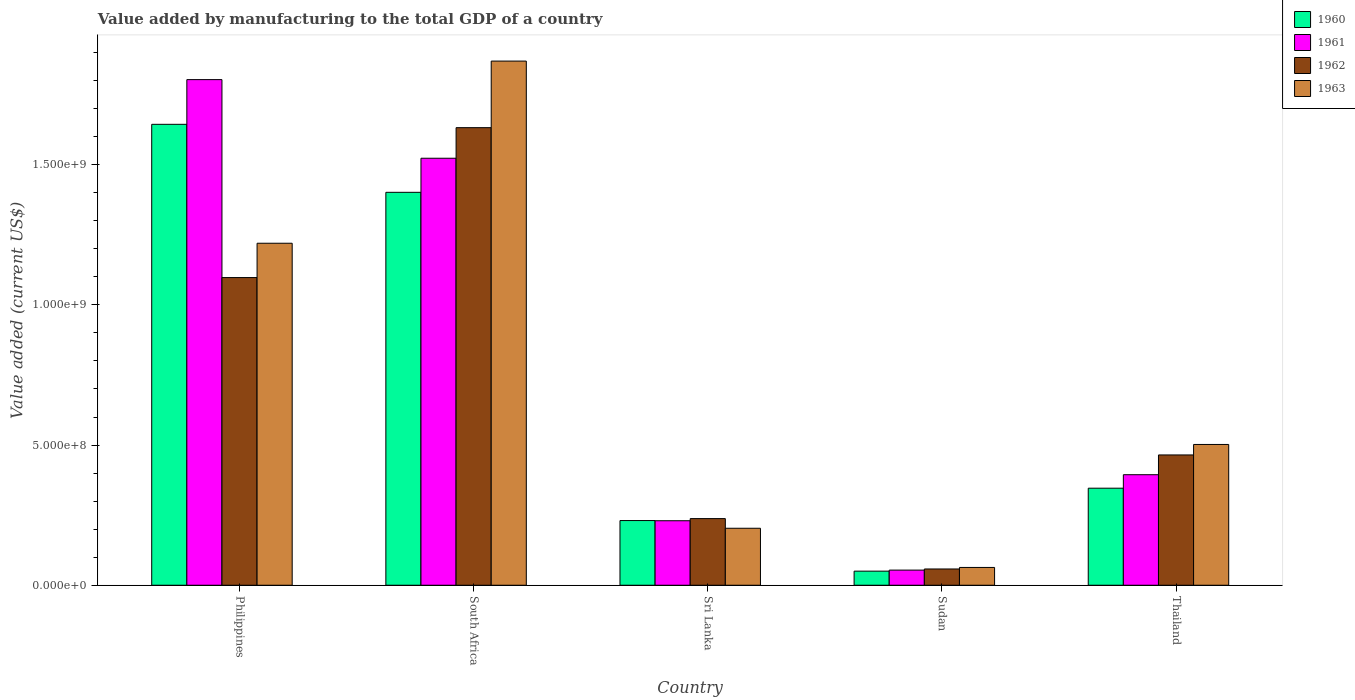How many different coloured bars are there?
Offer a terse response. 4. How many groups of bars are there?
Give a very brief answer. 5. Are the number of bars per tick equal to the number of legend labels?
Offer a terse response. Yes. Are the number of bars on each tick of the X-axis equal?
Keep it short and to the point. Yes. How many bars are there on the 2nd tick from the left?
Provide a succinct answer. 4. What is the label of the 5th group of bars from the left?
Give a very brief answer. Thailand. What is the value added by manufacturing to the total GDP in 1960 in South Africa?
Make the answer very short. 1.40e+09. Across all countries, what is the maximum value added by manufacturing to the total GDP in 1962?
Give a very brief answer. 1.63e+09. Across all countries, what is the minimum value added by manufacturing to the total GDP in 1961?
Provide a succinct answer. 5.40e+07. In which country was the value added by manufacturing to the total GDP in 1961 maximum?
Ensure brevity in your answer.  Philippines. In which country was the value added by manufacturing to the total GDP in 1961 minimum?
Make the answer very short. Sudan. What is the total value added by manufacturing to the total GDP in 1963 in the graph?
Your answer should be very brief. 3.86e+09. What is the difference between the value added by manufacturing to the total GDP in 1962 in South Africa and that in Thailand?
Your answer should be very brief. 1.17e+09. What is the difference between the value added by manufacturing to the total GDP in 1961 in Thailand and the value added by manufacturing to the total GDP in 1962 in Sudan?
Provide a short and direct response. 3.36e+08. What is the average value added by manufacturing to the total GDP in 1963 per country?
Keep it short and to the point. 7.72e+08. What is the difference between the value added by manufacturing to the total GDP of/in 1962 and value added by manufacturing to the total GDP of/in 1963 in Philippines?
Provide a succinct answer. -1.22e+08. In how many countries, is the value added by manufacturing to the total GDP in 1960 greater than 200000000 US$?
Offer a very short reply. 4. What is the ratio of the value added by manufacturing to the total GDP in 1963 in Sudan to that in Thailand?
Your answer should be compact. 0.13. Is the value added by manufacturing to the total GDP in 1963 in South Africa less than that in Sri Lanka?
Provide a short and direct response. No. Is the difference between the value added by manufacturing to the total GDP in 1962 in Philippines and Sudan greater than the difference between the value added by manufacturing to the total GDP in 1963 in Philippines and Sudan?
Ensure brevity in your answer.  No. What is the difference between the highest and the second highest value added by manufacturing to the total GDP in 1961?
Your answer should be compact. -1.13e+09. What is the difference between the highest and the lowest value added by manufacturing to the total GDP in 1963?
Your answer should be compact. 1.81e+09. In how many countries, is the value added by manufacturing to the total GDP in 1963 greater than the average value added by manufacturing to the total GDP in 1963 taken over all countries?
Provide a short and direct response. 2. Is the sum of the value added by manufacturing to the total GDP in 1962 in South Africa and Sri Lanka greater than the maximum value added by manufacturing to the total GDP in 1961 across all countries?
Provide a succinct answer. Yes. What does the 4th bar from the right in Sri Lanka represents?
Your response must be concise. 1960. How many bars are there?
Keep it short and to the point. 20. Are all the bars in the graph horizontal?
Your response must be concise. No. What is the difference between two consecutive major ticks on the Y-axis?
Your answer should be very brief. 5.00e+08. Are the values on the major ticks of Y-axis written in scientific E-notation?
Your answer should be very brief. Yes. Does the graph contain any zero values?
Provide a short and direct response. No. Does the graph contain grids?
Offer a very short reply. No. How many legend labels are there?
Your response must be concise. 4. How are the legend labels stacked?
Offer a terse response. Vertical. What is the title of the graph?
Your answer should be very brief. Value added by manufacturing to the total GDP of a country. Does "1960" appear as one of the legend labels in the graph?
Offer a very short reply. Yes. What is the label or title of the Y-axis?
Provide a short and direct response. Value added (current US$). What is the Value added (current US$) of 1960 in Philippines?
Your response must be concise. 1.64e+09. What is the Value added (current US$) of 1961 in Philippines?
Give a very brief answer. 1.80e+09. What is the Value added (current US$) in 1962 in Philippines?
Your answer should be very brief. 1.10e+09. What is the Value added (current US$) of 1963 in Philippines?
Your answer should be very brief. 1.22e+09. What is the Value added (current US$) in 1960 in South Africa?
Provide a succinct answer. 1.40e+09. What is the Value added (current US$) in 1961 in South Africa?
Give a very brief answer. 1.52e+09. What is the Value added (current US$) in 1962 in South Africa?
Make the answer very short. 1.63e+09. What is the Value added (current US$) in 1963 in South Africa?
Ensure brevity in your answer.  1.87e+09. What is the Value added (current US$) of 1960 in Sri Lanka?
Ensure brevity in your answer.  2.31e+08. What is the Value added (current US$) in 1961 in Sri Lanka?
Provide a short and direct response. 2.30e+08. What is the Value added (current US$) of 1962 in Sri Lanka?
Your response must be concise. 2.38e+08. What is the Value added (current US$) in 1963 in Sri Lanka?
Give a very brief answer. 2.03e+08. What is the Value added (current US$) of 1960 in Sudan?
Provide a short and direct response. 5.03e+07. What is the Value added (current US$) of 1961 in Sudan?
Provide a short and direct response. 5.40e+07. What is the Value added (current US$) of 1962 in Sudan?
Your answer should be very brief. 5.80e+07. What is the Value added (current US$) of 1963 in Sudan?
Provide a succinct answer. 6.35e+07. What is the Value added (current US$) in 1960 in Thailand?
Make the answer very short. 3.46e+08. What is the Value added (current US$) of 1961 in Thailand?
Your answer should be very brief. 3.94e+08. What is the Value added (current US$) of 1962 in Thailand?
Your answer should be very brief. 4.65e+08. What is the Value added (current US$) of 1963 in Thailand?
Give a very brief answer. 5.02e+08. Across all countries, what is the maximum Value added (current US$) of 1960?
Your response must be concise. 1.64e+09. Across all countries, what is the maximum Value added (current US$) in 1961?
Offer a very short reply. 1.80e+09. Across all countries, what is the maximum Value added (current US$) in 1962?
Keep it short and to the point. 1.63e+09. Across all countries, what is the maximum Value added (current US$) of 1963?
Ensure brevity in your answer.  1.87e+09. Across all countries, what is the minimum Value added (current US$) in 1960?
Give a very brief answer. 5.03e+07. Across all countries, what is the minimum Value added (current US$) of 1961?
Ensure brevity in your answer.  5.40e+07. Across all countries, what is the minimum Value added (current US$) of 1962?
Make the answer very short. 5.80e+07. Across all countries, what is the minimum Value added (current US$) in 1963?
Keep it short and to the point. 6.35e+07. What is the total Value added (current US$) in 1960 in the graph?
Keep it short and to the point. 3.67e+09. What is the total Value added (current US$) of 1961 in the graph?
Give a very brief answer. 4.00e+09. What is the total Value added (current US$) of 1962 in the graph?
Ensure brevity in your answer.  3.49e+09. What is the total Value added (current US$) of 1963 in the graph?
Provide a succinct answer. 3.86e+09. What is the difference between the Value added (current US$) in 1960 in Philippines and that in South Africa?
Give a very brief answer. 2.43e+08. What is the difference between the Value added (current US$) in 1961 in Philippines and that in South Africa?
Ensure brevity in your answer.  2.80e+08. What is the difference between the Value added (current US$) of 1962 in Philippines and that in South Africa?
Give a very brief answer. -5.35e+08. What is the difference between the Value added (current US$) in 1963 in Philippines and that in South Africa?
Your answer should be compact. -6.50e+08. What is the difference between the Value added (current US$) in 1960 in Philippines and that in Sri Lanka?
Your answer should be very brief. 1.41e+09. What is the difference between the Value added (current US$) of 1961 in Philippines and that in Sri Lanka?
Your answer should be compact. 1.57e+09. What is the difference between the Value added (current US$) of 1962 in Philippines and that in Sri Lanka?
Provide a short and direct response. 8.60e+08. What is the difference between the Value added (current US$) of 1963 in Philippines and that in Sri Lanka?
Offer a terse response. 1.02e+09. What is the difference between the Value added (current US$) of 1960 in Philippines and that in Sudan?
Your answer should be compact. 1.59e+09. What is the difference between the Value added (current US$) in 1961 in Philippines and that in Sudan?
Provide a short and direct response. 1.75e+09. What is the difference between the Value added (current US$) of 1962 in Philippines and that in Sudan?
Provide a short and direct response. 1.04e+09. What is the difference between the Value added (current US$) of 1963 in Philippines and that in Sudan?
Provide a short and direct response. 1.16e+09. What is the difference between the Value added (current US$) of 1960 in Philippines and that in Thailand?
Give a very brief answer. 1.30e+09. What is the difference between the Value added (current US$) in 1961 in Philippines and that in Thailand?
Ensure brevity in your answer.  1.41e+09. What is the difference between the Value added (current US$) of 1962 in Philippines and that in Thailand?
Offer a very short reply. 6.33e+08. What is the difference between the Value added (current US$) of 1963 in Philippines and that in Thailand?
Give a very brief answer. 7.18e+08. What is the difference between the Value added (current US$) of 1960 in South Africa and that in Sri Lanka?
Provide a short and direct response. 1.17e+09. What is the difference between the Value added (current US$) of 1961 in South Africa and that in Sri Lanka?
Give a very brief answer. 1.29e+09. What is the difference between the Value added (current US$) of 1962 in South Africa and that in Sri Lanka?
Keep it short and to the point. 1.39e+09. What is the difference between the Value added (current US$) in 1963 in South Africa and that in Sri Lanka?
Provide a short and direct response. 1.67e+09. What is the difference between the Value added (current US$) in 1960 in South Africa and that in Sudan?
Make the answer very short. 1.35e+09. What is the difference between the Value added (current US$) of 1961 in South Africa and that in Sudan?
Your answer should be compact. 1.47e+09. What is the difference between the Value added (current US$) of 1962 in South Africa and that in Sudan?
Your answer should be compact. 1.57e+09. What is the difference between the Value added (current US$) of 1963 in South Africa and that in Sudan?
Make the answer very short. 1.81e+09. What is the difference between the Value added (current US$) in 1960 in South Africa and that in Thailand?
Make the answer very short. 1.06e+09. What is the difference between the Value added (current US$) in 1961 in South Africa and that in Thailand?
Offer a very short reply. 1.13e+09. What is the difference between the Value added (current US$) in 1962 in South Africa and that in Thailand?
Your answer should be very brief. 1.17e+09. What is the difference between the Value added (current US$) of 1963 in South Africa and that in Thailand?
Ensure brevity in your answer.  1.37e+09. What is the difference between the Value added (current US$) in 1960 in Sri Lanka and that in Sudan?
Your response must be concise. 1.80e+08. What is the difference between the Value added (current US$) of 1961 in Sri Lanka and that in Sudan?
Your response must be concise. 1.76e+08. What is the difference between the Value added (current US$) of 1962 in Sri Lanka and that in Sudan?
Offer a terse response. 1.80e+08. What is the difference between the Value added (current US$) in 1963 in Sri Lanka and that in Sudan?
Offer a very short reply. 1.40e+08. What is the difference between the Value added (current US$) of 1960 in Sri Lanka and that in Thailand?
Your answer should be very brief. -1.15e+08. What is the difference between the Value added (current US$) of 1961 in Sri Lanka and that in Thailand?
Your answer should be compact. -1.64e+08. What is the difference between the Value added (current US$) of 1962 in Sri Lanka and that in Thailand?
Give a very brief answer. -2.27e+08. What is the difference between the Value added (current US$) of 1963 in Sri Lanka and that in Thailand?
Provide a short and direct response. -2.99e+08. What is the difference between the Value added (current US$) in 1960 in Sudan and that in Thailand?
Your answer should be compact. -2.96e+08. What is the difference between the Value added (current US$) in 1961 in Sudan and that in Thailand?
Provide a succinct answer. -3.40e+08. What is the difference between the Value added (current US$) of 1962 in Sudan and that in Thailand?
Your response must be concise. -4.07e+08. What is the difference between the Value added (current US$) in 1963 in Sudan and that in Thailand?
Ensure brevity in your answer.  -4.39e+08. What is the difference between the Value added (current US$) in 1960 in Philippines and the Value added (current US$) in 1961 in South Africa?
Ensure brevity in your answer.  1.21e+08. What is the difference between the Value added (current US$) of 1960 in Philippines and the Value added (current US$) of 1962 in South Africa?
Give a very brief answer. 1.19e+07. What is the difference between the Value added (current US$) of 1960 in Philippines and the Value added (current US$) of 1963 in South Africa?
Make the answer very short. -2.26e+08. What is the difference between the Value added (current US$) of 1961 in Philippines and the Value added (current US$) of 1962 in South Africa?
Provide a short and direct response. 1.71e+08. What is the difference between the Value added (current US$) of 1961 in Philippines and the Value added (current US$) of 1963 in South Africa?
Ensure brevity in your answer.  -6.61e+07. What is the difference between the Value added (current US$) of 1962 in Philippines and the Value added (current US$) of 1963 in South Africa?
Keep it short and to the point. -7.72e+08. What is the difference between the Value added (current US$) of 1960 in Philippines and the Value added (current US$) of 1961 in Sri Lanka?
Your answer should be compact. 1.41e+09. What is the difference between the Value added (current US$) of 1960 in Philippines and the Value added (current US$) of 1962 in Sri Lanka?
Ensure brevity in your answer.  1.41e+09. What is the difference between the Value added (current US$) of 1960 in Philippines and the Value added (current US$) of 1963 in Sri Lanka?
Your response must be concise. 1.44e+09. What is the difference between the Value added (current US$) of 1961 in Philippines and the Value added (current US$) of 1962 in Sri Lanka?
Your answer should be very brief. 1.57e+09. What is the difference between the Value added (current US$) in 1961 in Philippines and the Value added (current US$) in 1963 in Sri Lanka?
Provide a short and direct response. 1.60e+09. What is the difference between the Value added (current US$) of 1962 in Philippines and the Value added (current US$) of 1963 in Sri Lanka?
Ensure brevity in your answer.  8.94e+08. What is the difference between the Value added (current US$) in 1960 in Philippines and the Value added (current US$) in 1961 in Sudan?
Your answer should be compact. 1.59e+09. What is the difference between the Value added (current US$) of 1960 in Philippines and the Value added (current US$) of 1962 in Sudan?
Provide a succinct answer. 1.59e+09. What is the difference between the Value added (current US$) in 1960 in Philippines and the Value added (current US$) in 1963 in Sudan?
Give a very brief answer. 1.58e+09. What is the difference between the Value added (current US$) of 1961 in Philippines and the Value added (current US$) of 1962 in Sudan?
Provide a short and direct response. 1.75e+09. What is the difference between the Value added (current US$) of 1961 in Philippines and the Value added (current US$) of 1963 in Sudan?
Provide a succinct answer. 1.74e+09. What is the difference between the Value added (current US$) in 1962 in Philippines and the Value added (current US$) in 1963 in Sudan?
Provide a short and direct response. 1.03e+09. What is the difference between the Value added (current US$) of 1960 in Philippines and the Value added (current US$) of 1961 in Thailand?
Your response must be concise. 1.25e+09. What is the difference between the Value added (current US$) in 1960 in Philippines and the Value added (current US$) in 1962 in Thailand?
Provide a succinct answer. 1.18e+09. What is the difference between the Value added (current US$) in 1960 in Philippines and the Value added (current US$) in 1963 in Thailand?
Your answer should be very brief. 1.14e+09. What is the difference between the Value added (current US$) in 1961 in Philippines and the Value added (current US$) in 1962 in Thailand?
Make the answer very short. 1.34e+09. What is the difference between the Value added (current US$) of 1961 in Philippines and the Value added (current US$) of 1963 in Thailand?
Offer a terse response. 1.30e+09. What is the difference between the Value added (current US$) of 1962 in Philippines and the Value added (current US$) of 1963 in Thailand?
Keep it short and to the point. 5.95e+08. What is the difference between the Value added (current US$) of 1960 in South Africa and the Value added (current US$) of 1961 in Sri Lanka?
Offer a terse response. 1.17e+09. What is the difference between the Value added (current US$) of 1960 in South Africa and the Value added (current US$) of 1962 in Sri Lanka?
Your response must be concise. 1.16e+09. What is the difference between the Value added (current US$) in 1960 in South Africa and the Value added (current US$) in 1963 in Sri Lanka?
Your response must be concise. 1.20e+09. What is the difference between the Value added (current US$) of 1961 in South Africa and the Value added (current US$) of 1962 in Sri Lanka?
Give a very brief answer. 1.29e+09. What is the difference between the Value added (current US$) of 1961 in South Africa and the Value added (current US$) of 1963 in Sri Lanka?
Provide a succinct answer. 1.32e+09. What is the difference between the Value added (current US$) of 1962 in South Africa and the Value added (current US$) of 1963 in Sri Lanka?
Your response must be concise. 1.43e+09. What is the difference between the Value added (current US$) in 1960 in South Africa and the Value added (current US$) in 1961 in Sudan?
Your response must be concise. 1.35e+09. What is the difference between the Value added (current US$) in 1960 in South Africa and the Value added (current US$) in 1962 in Sudan?
Your answer should be very brief. 1.34e+09. What is the difference between the Value added (current US$) of 1960 in South Africa and the Value added (current US$) of 1963 in Sudan?
Your answer should be very brief. 1.34e+09. What is the difference between the Value added (current US$) of 1961 in South Africa and the Value added (current US$) of 1962 in Sudan?
Ensure brevity in your answer.  1.46e+09. What is the difference between the Value added (current US$) in 1961 in South Africa and the Value added (current US$) in 1963 in Sudan?
Your answer should be very brief. 1.46e+09. What is the difference between the Value added (current US$) of 1962 in South Africa and the Value added (current US$) of 1963 in Sudan?
Your answer should be very brief. 1.57e+09. What is the difference between the Value added (current US$) in 1960 in South Africa and the Value added (current US$) in 1961 in Thailand?
Offer a very short reply. 1.01e+09. What is the difference between the Value added (current US$) in 1960 in South Africa and the Value added (current US$) in 1962 in Thailand?
Keep it short and to the point. 9.37e+08. What is the difference between the Value added (current US$) in 1960 in South Africa and the Value added (current US$) in 1963 in Thailand?
Offer a terse response. 8.99e+08. What is the difference between the Value added (current US$) in 1961 in South Africa and the Value added (current US$) in 1962 in Thailand?
Your response must be concise. 1.06e+09. What is the difference between the Value added (current US$) of 1961 in South Africa and the Value added (current US$) of 1963 in Thailand?
Give a very brief answer. 1.02e+09. What is the difference between the Value added (current US$) in 1962 in South Africa and the Value added (current US$) in 1963 in Thailand?
Make the answer very short. 1.13e+09. What is the difference between the Value added (current US$) in 1960 in Sri Lanka and the Value added (current US$) in 1961 in Sudan?
Your answer should be compact. 1.77e+08. What is the difference between the Value added (current US$) of 1960 in Sri Lanka and the Value added (current US$) of 1962 in Sudan?
Make the answer very short. 1.73e+08. What is the difference between the Value added (current US$) in 1960 in Sri Lanka and the Value added (current US$) in 1963 in Sudan?
Provide a succinct answer. 1.67e+08. What is the difference between the Value added (current US$) in 1961 in Sri Lanka and the Value added (current US$) in 1962 in Sudan?
Keep it short and to the point. 1.72e+08. What is the difference between the Value added (current US$) of 1961 in Sri Lanka and the Value added (current US$) of 1963 in Sudan?
Provide a succinct answer. 1.67e+08. What is the difference between the Value added (current US$) in 1962 in Sri Lanka and the Value added (current US$) in 1963 in Sudan?
Your response must be concise. 1.74e+08. What is the difference between the Value added (current US$) of 1960 in Sri Lanka and the Value added (current US$) of 1961 in Thailand?
Ensure brevity in your answer.  -1.64e+08. What is the difference between the Value added (current US$) of 1960 in Sri Lanka and the Value added (current US$) of 1962 in Thailand?
Your answer should be very brief. -2.34e+08. What is the difference between the Value added (current US$) of 1960 in Sri Lanka and the Value added (current US$) of 1963 in Thailand?
Ensure brevity in your answer.  -2.71e+08. What is the difference between the Value added (current US$) of 1961 in Sri Lanka and the Value added (current US$) of 1962 in Thailand?
Provide a short and direct response. -2.35e+08. What is the difference between the Value added (current US$) in 1961 in Sri Lanka and the Value added (current US$) in 1963 in Thailand?
Provide a short and direct response. -2.72e+08. What is the difference between the Value added (current US$) in 1962 in Sri Lanka and the Value added (current US$) in 1963 in Thailand?
Make the answer very short. -2.64e+08. What is the difference between the Value added (current US$) of 1960 in Sudan and the Value added (current US$) of 1961 in Thailand?
Provide a short and direct response. -3.44e+08. What is the difference between the Value added (current US$) of 1960 in Sudan and the Value added (current US$) of 1962 in Thailand?
Provide a short and direct response. -4.14e+08. What is the difference between the Value added (current US$) in 1960 in Sudan and the Value added (current US$) in 1963 in Thailand?
Your answer should be compact. -4.52e+08. What is the difference between the Value added (current US$) in 1961 in Sudan and the Value added (current US$) in 1962 in Thailand?
Ensure brevity in your answer.  -4.11e+08. What is the difference between the Value added (current US$) of 1961 in Sudan and the Value added (current US$) of 1963 in Thailand?
Your response must be concise. -4.48e+08. What is the difference between the Value added (current US$) in 1962 in Sudan and the Value added (current US$) in 1963 in Thailand?
Provide a succinct answer. -4.44e+08. What is the average Value added (current US$) in 1960 per country?
Offer a very short reply. 7.34e+08. What is the average Value added (current US$) in 1961 per country?
Your answer should be compact. 8.01e+08. What is the average Value added (current US$) of 1962 per country?
Offer a very short reply. 6.98e+08. What is the average Value added (current US$) of 1963 per country?
Offer a terse response. 7.72e+08. What is the difference between the Value added (current US$) in 1960 and Value added (current US$) in 1961 in Philippines?
Your response must be concise. -1.59e+08. What is the difference between the Value added (current US$) of 1960 and Value added (current US$) of 1962 in Philippines?
Give a very brief answer. 5.47e+08. What is the difference between the Value added (current US$) in 1960 and Value added (current US$) in 1963 in Philippines?
Make the answer very short. 4.24e+08. What is the difference between the Value added (current US$) in 1961 and Value added (current US$) in 1962 in Philippines?
Provide a succinct answer. 7.06e+08. What is the difference between the Value added (current US$) in 1961 and Value added (current US$) in 1963 in Philippines?
Provide a short and direct response. 5.84e+08. What is the difference between the Value added (current US$) of 1962 and Value added (current US$) of 1963 in Philippines?
Ensure brevity in your answer.  -1.22e+08. What is the difference between the Value added (current US$) in 1960 and Value added (current US$) in 1961 in South Africa?
Your answer should be compact. -1.21e+08. What is the difference between the Value added (current US$) in 1960 and Value added (current US$) in 1962 in South Africa?
Provide a succinct answer. -2.31e+08. What is the difference between the Value added (current US$) of 1960 and Value added (current US$) of 1963 in South Africa?
Provide a short and direct response. -4.68e+08. What is the difference between the Value added (current US$) in 1961 and Value added (current US$) in 1962 in South Africa?
Your response must be concise. -1.09e+08. What is the difference between the Value added (current US$) in 1961 and Value added (current US$) in 1963 in South Africa?
Provide a succinct answer. -3.47e+08. What is the difference between the Value added (current US$) in 1962 and Value added (current US$) in 1963 in South Africa?
Provide a succinct answer. -2.37e+08. What is the difference between the Value added (current US$) of 1960 and Value added (current US$) of 1961 in Sri Lanka?
Your answer should be very brief. 6.30e+05. What is the difference between the Value added (current US$) in 1960 and Value added (current US$) in 1962 in Sri Lanka?
Make the answer very short. -6.98e+06. What is the difference between the Value added (current US$) of 1960 and Value added (current US$) of 1963 in Sri Lanka?
Offer a terse response. 2.75e+07. What is the difference between the Value added (current US$) of 1961 and Value added (current US$) of 1962 in Sri Lanka?
Offer a very short reply. -7.61e+06. What is the difference between the Value added (current US$) in 1961 and Value added (current US$) in 1963 in Sri Lanka?
Your response must be concise. 2.68e+07. What is the difference between the Value added (current US$) in 1962 and Value added (current US$) in 1963 in Sri Lanka?
Offer a very short reply. 3.45e+07. What is the difference between the Value added (current US$) of 1960 and Value added (current US$) of 1961 in Sudan?
Offer a terse response. -3.73e+06. What is the difference between the Value added (current US$) of 1960 and Value added (current US$) of 1962 in Sudan?
Your answer should be compact. -7.75e+06. What is the difference between the Value added (current US$) in 1960 and Value added (current US$) in 1963 in Sudan?
Keep it short and to the point. -1.32e+07. What is the difference between the Value added (current US$) of 1961 and Value added (current US$) of 1962 in Sudan?
Provide a short and direct response. -4.02e+06. What is the difference between the Value added (current US$) of 1961 and Value added (current US$) of 1963 in Sudan?
Offer a terse response. -9.48e+06. What is the difference between the Value added (current US$) in 1962 and Value added (current US$) in 1963 in Sudan?
Offer a very short reply. -5.46e+06. What is the difference between the Value added (current US$) in 1960 and Value added (current US$) in 1961 in Thailand?
Ensure brevity in your answer.  -4.81e+07. What is the difference between the Value added (current US$) in 1960 and Value added (current US$) in 1962 in Thailand?
Ensure brevity in your answer.  -1.19e+08. What is the difference between the Value added (current US$) in 1960 and Value added (current US$) in 1963 in Thailand?
Keep it short and to the point. -1.56e+08. What is the difference between the Value added (current US$) of 1961 and Value added (current US$) of 1962 in Thailand?
Your answer should be compact. -7.05e+07. What is the difference between the Value added (current US$) of 1961 and Value added (current US$) of 1963 in Thailand?
Give a very brief answer. -1.08e+08. What is the difference between the Value added (current US$) of 1962 and Value added (current US$) of 1963 in Thailand?
Offer a very short reply. -3.73e+07. What is the ratio of the Value added (current US$) in 1960 in Philippines to that in South Africa?
Give a very brief answer. 1.17. What is the ratio of the Value added (current US$) in 1961 in Philippines to that in South Africa?
Provide a short and direct response. 1.18. What is the ratio of the Value added (current US$) in 1962 in Philippines to that in South Africa?
Provide a short and direct response. 0.67. What is the ratio of the Value added (current US$) in 1963 in Philippines to that in South Africa?
Provide a succinct answer. 0.65. What is the ratio of the Value added (current US$) in 1960 in Philippines to that in Sri Lanka?
Give a very brief answer. 7.13. What is the ratio of the Value added (current US$) in 1961 in Philippines to that in Sri Lanka?
Ensure brevity in your answer.  7.84. What is the ratio of the Value added (current US$) of 1962 in Philippines to that in Sri Lanka?
Make the answer very short. 4.62. What is the ratio of the Value added (current US$) in 1963 in Philippines to that in Sri Lanka?
Your answer should be compact. 6. What is the ratio of the Value added (current US$) of 1960 in Philippines to that in Sudan?
Offer a very short reply. 32.71. What is the ratio of the Value added (current US$) of 1961 in Philippines to that in Sudan?
Offer a very short reply. 33.4. What is the ratio of the Value added (current US$) of 1962 in Philippines to that in Sudan?
Offer a terse response. 18.91. What is the ratio of the Value added (current US$) in 1963 in Philippines to that in Sudan?
Give a very brief answer. 19.22. What is the ratio of the Value added (current US$) of 1960 in Philippines to that in Thailand?
Give a very brief answer. 4.75. What is the ratio of the Value added (current US$) of 1961 in Philippines to that in Thailand?
Provide a succinct answer. 4.57. What is the ratio of the Value added (current US$) in 1962 in Philippines to that in Thailand?
Offer a terse response. 2.36. What is the ratio of the Value added (current US$) of 1963 in Philippines to that in Thailand?
Make the answer very short. 2.43. What is the ratio of the Value added (current US$) of 1960 in South Africa to that in Sri Lanka?
Your answer should be very brief. 6.08. What is the ratio of the Value added (current US$) in 1961 in South Africa to that in Sri Lanka?
Your response must be concise. 6.62. What is the ratio of the Value added (current US$) in 1962 in South Africa to that in Sri Lanka?
Offer a very short reply. 6.87. What is the ratio of the Value added (current US$) of 1963 in South Africa to that in Sri Lanka?
Your response must be concise. 9.2. What is the ratio of the Value added (current US$) of 1960 in South Africa to that in Sudan?
Offer a terse response. 27.88. What is the ratio of the Value added (current US$) in 1961 in South Africa to that in Sudan?
Provide a short and direct response. 28.21. What is the ratio of the Value added (current US$) in 1962 in South Africa to that in Sudan?
Provide a succinct answer. 28.13. What is the ratio of the Value added (current US$) in 1963 in South Africa to that in Sudan?
Offer a very short reply. 29.45. What is the ratio of the Value added (current US$) of 1960 in South Africa to that in Thailand?
Your answer should be very brief. 4.05. What is the ratio of the Value added (current US$) of 1961 in South Africa to that in Thailand?
Ensure brevity in your answer.  3.86. What is the ratio of the Value added (current US$) of 1962 in South Africa to that in Thailand?
Make the answer very short. 3.51. What is the ratio of the Value added (current US$) in 1963 in South Africa to that in Thailand?
Ensure brevity in your answer.  3.72. What is the ratio of the Value added (current US$) in 1960 in Sri Lanka to that in Sudan?
Ensure brevity in your answer.  4.59. What is the ratio of the Value added (current US$) of 1961 in Sri Lanka to that in Sudan?
Provide a succinct answer. 4.26. What is the ratio of the Value added (current US$) of 1962 in Sri Lanka to that in Sudan?
Provide a short and direct response. 4.1. What is the ratio of the Value added (current US$) of 1963 in Sri Lanka to that in Sudan?
Ensure brevity in your answer.  3.2. What is the ratio of the Value added (current US$) in 1960 in Sri Lanka to that in Thailand?
Your response must be concise. 0.67. What is the ratio of the Value added (current US$) of 1961 in Sri Lanka to that in Thailand?
Give a very brief answer. 0.58. What is the ratio of the Value added (current US$) in 1962 in Sri Lanka to that in Thailand?
Offer a very short reply. 0.51. What is the ratio of the Value added (current US$) of 1963 in Sri Lanka to that in Thailand?
Your response must be concise. 0.4. What is the ratio of the Value added (current US$) in 1960 in Sudan to that in Thailand?
Offer a terse response. 0.15. What is the ratio of the Value added (current US$) in 1961 in Sudan to that in Thailand?
Your answer should be compact. 0.14. What is the ratio of the Value added (current US$) of 1962 in Sudan to that in Thailand?
Your answer should be compact. 0.12. What is the ratio of the Value added (current US$) in 1963 in Sudan to that in Thailand?
Your answer should be very brief. 0.13. What is the difference between the highest and the second highest Value added (current US$) of 1960?
Your response must be concise. 2.43e+08. What is the difference between the highest and the second highest Value added (current US$) in 1961?
Ensure brevity in your answer.  2.80e+08. What is the difference between the highest and the second highest Value added (current US$) in 1962?
Offer a very short reply. 5.35e+08. What is the difference between the highest and the second highest Value added (current US$) of 1963?
Your answer should be compact. 6.50e+08. What is the difference between the highest and the lowest Value added (current US$) of 1960?
Your response must be concise. 1.59e+09. What is the difference between the highest and the lowest Value added (current US$) in 1961?
Offer a very short reply. 1.75e+09. What is the difference between the highest and the lowest Value added (current US$) of 1962?
Your answer should be compact. 1.57e+09. What is the difference between the highest and the lowest Value added (current US$) of 1963?
Give a very brief answer. 1.81e+09. 